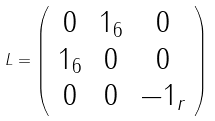<formula> <loc_0><loc_0><loc_500><loc_500>L = \left ( \begin{array} { c c c } 0 & 1 _ { 6 } & 0 \\ 1 _ { 6 } & 0 & 0 \\ 0 & 0 & - 1 _ { r } \end{array} \right )</formula> 